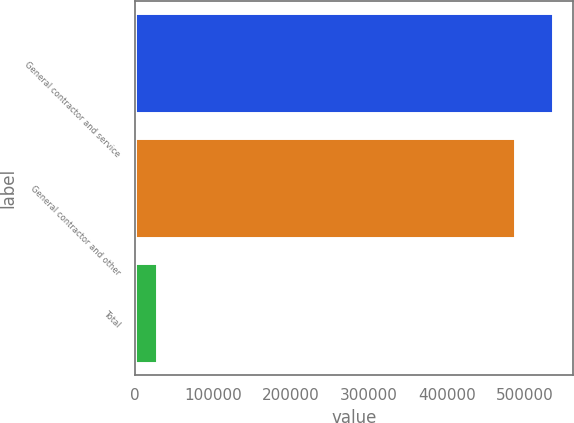<chart> <loc_0><loc_0><loc_500><loc_500><bar_chart><fcel>General contractor and service<fcel>General contractor and other<fcel>Total<nl><fcel>535552<fcel>486865<fcel>28496<nl></chart> 